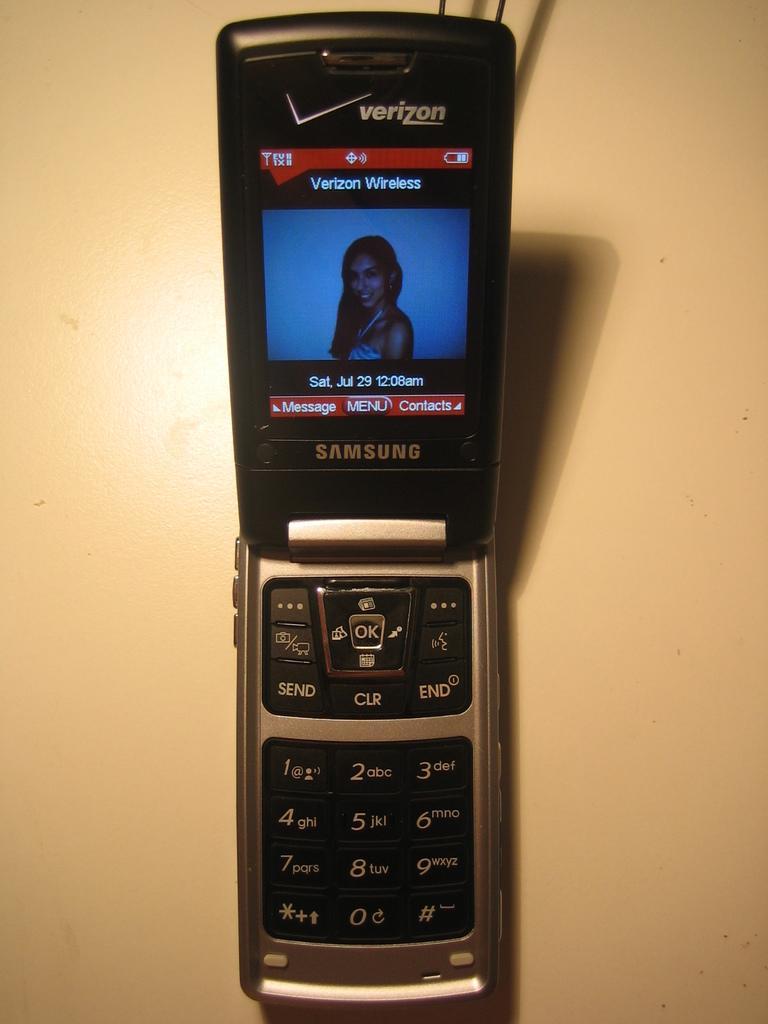Describe this image in one or two sentences. In the center of this picture we can see a mobile phone and we can see the text, numbers and a picture of a woman on the display of the mobile phone. In the background we can see an object which seems to be the table. 